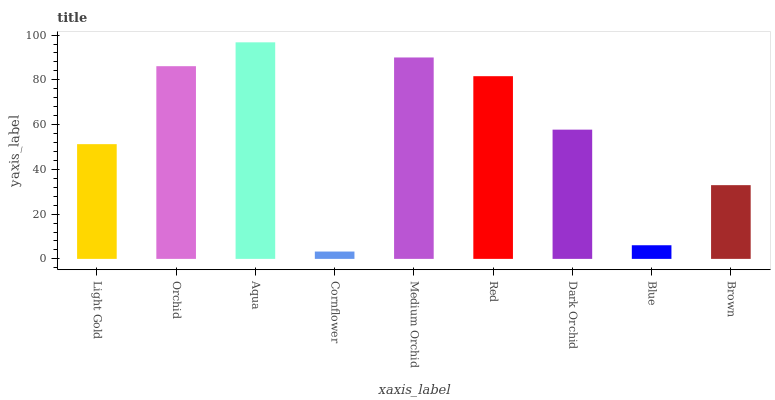Is Cornflower the minimum?
Answer yes or no. Yes. Is Aqua the maximum?
Answer yes or no. Yes. Is Orchid the minimum?
Answer yes or no. No. Is Orchid the maximum?
Answer yes or no. No. Is Orchid greater than Light Gold?
Answer yes or no. Yes. Is Light Gold less than Orchid?
Answer yes or no. Yes. Is Light Gold greater than Orchid?
Answer yes or no. No. Is Orchid less than Light Gold?
Answer yes or no. No. Is Dark Orchid the high median?
Answer yes or no. Yes. Is Dark Orchid the low median?
Answer yes or no. Yes. Is Cornflower the high median?
Answer yes or no. No. Is Medium Orchid the low median?
Answer yes or no. No. 